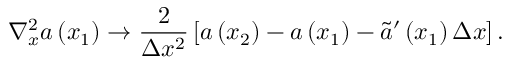Convert formula to latex. <formula><loc_0><loc_0><loc_500><loc_500>\nabla _ { x } ^ { 2 } a \left ( x _ { 1 } \right ) \rightarrow \frac { 2 } { \Delta x ^ { 2 } } \left [ a \left ( x _ { 2 } \right ) - a \left ( x _ { 1 } \right ) - \tilde { a } ^ { \prime } \left ( x _ { 1 } \right ) \Delta x \right ] .</formula> 